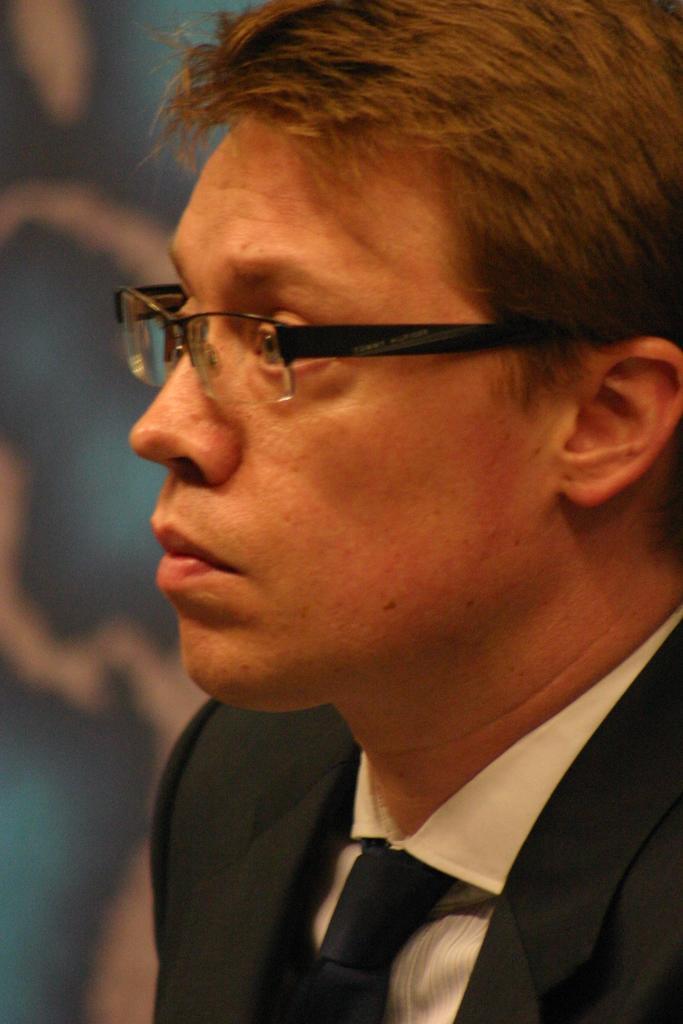In one or two sentences, can you explain what this image depicts? In this image we can see a person wearing a black suit and a tie. 